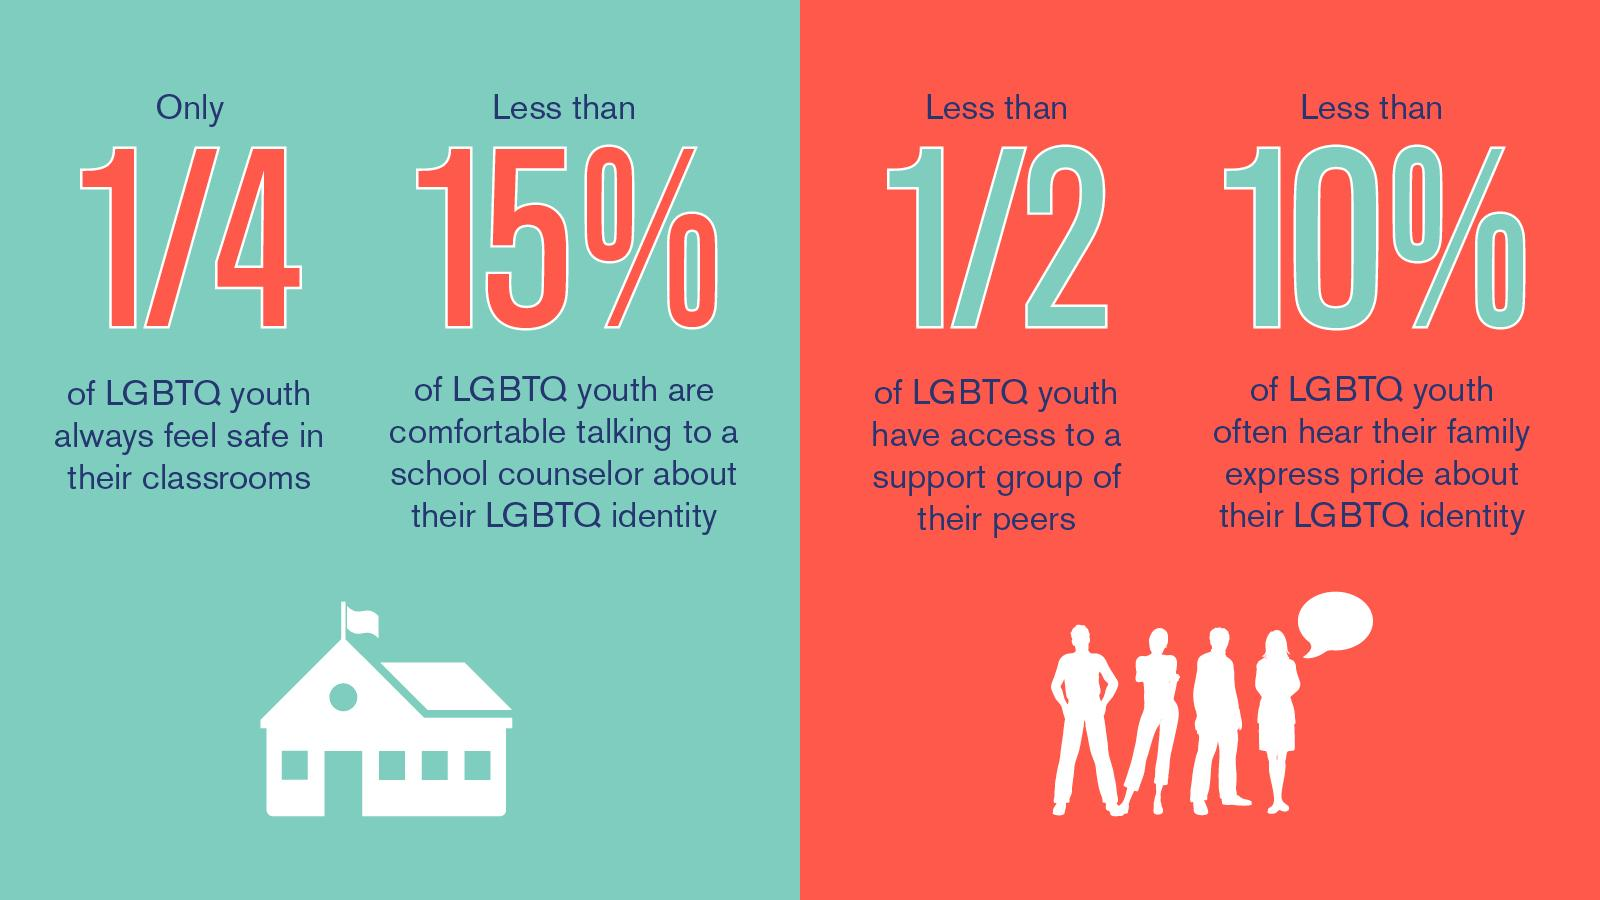Draw attention to some important aspects in this diagram. According to a recent survey, over three-quarters of LGBTQ youth do not feel safe in their classrooms. According to a recent survey, less than 15% of LGBTQ youth feel comfortable discussing their issues with a school counselor. According to research, it is estimated that less than 10% of LGBTQ youth often hear their family express pride about their identity. 